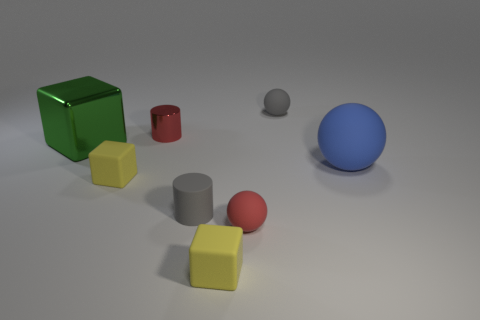There is a small rubber object that is the same shape as the small red metallic thing; what color is it? gray 